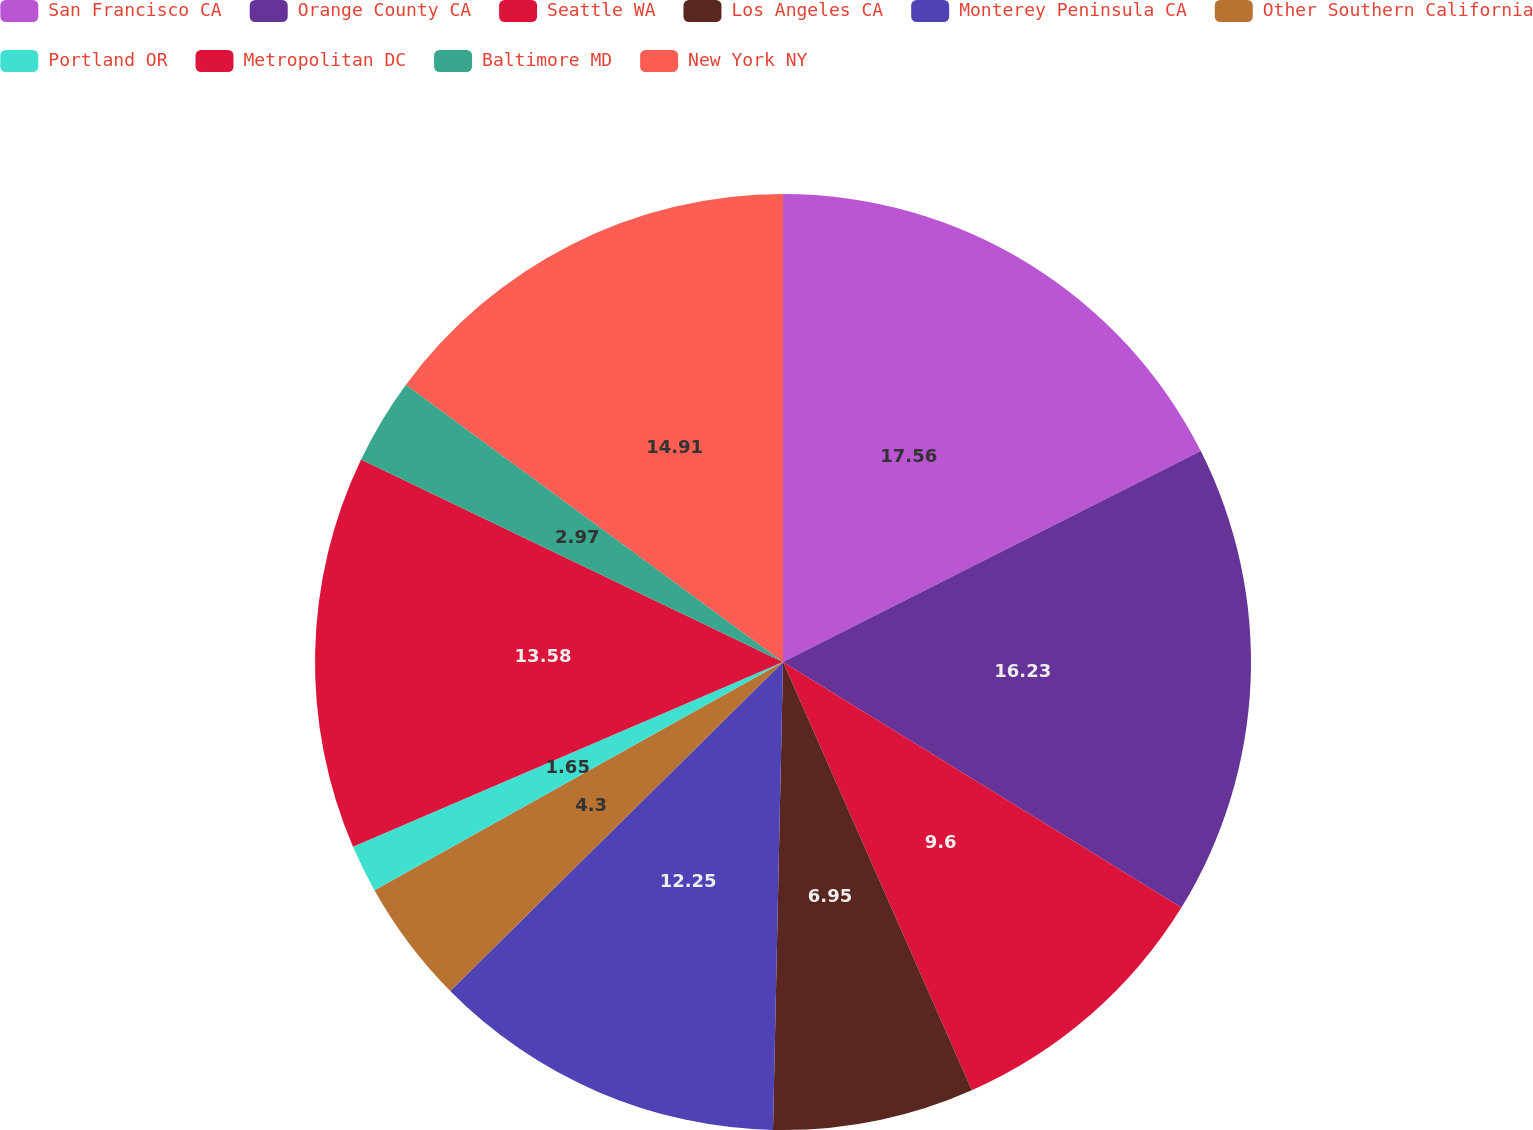Convert chart to OTSL. <chart><loc_0><loc_0><loc_500><loc_500><pie_chart><fcel>San Francisco CA<fcel>Orange County CA<fcel>Seattle WA<fcel>Los Angeles CA<fcel>Monterey Peninsula CA<fcel>Other Southern California<fcel>Portland OR<fcel>Metropolitan DC<fcel>Baltimore MD<fcel>New York NY<nl><fcel>17.56%<fcel>16.23%<fcel>9.6%<fcel>6.95%<fcel>12.25%<fcel>4.3%<fcel>1.65%<fcel>13.58%<fcel>2.97%<fcel>14.91%<nl></chart> 